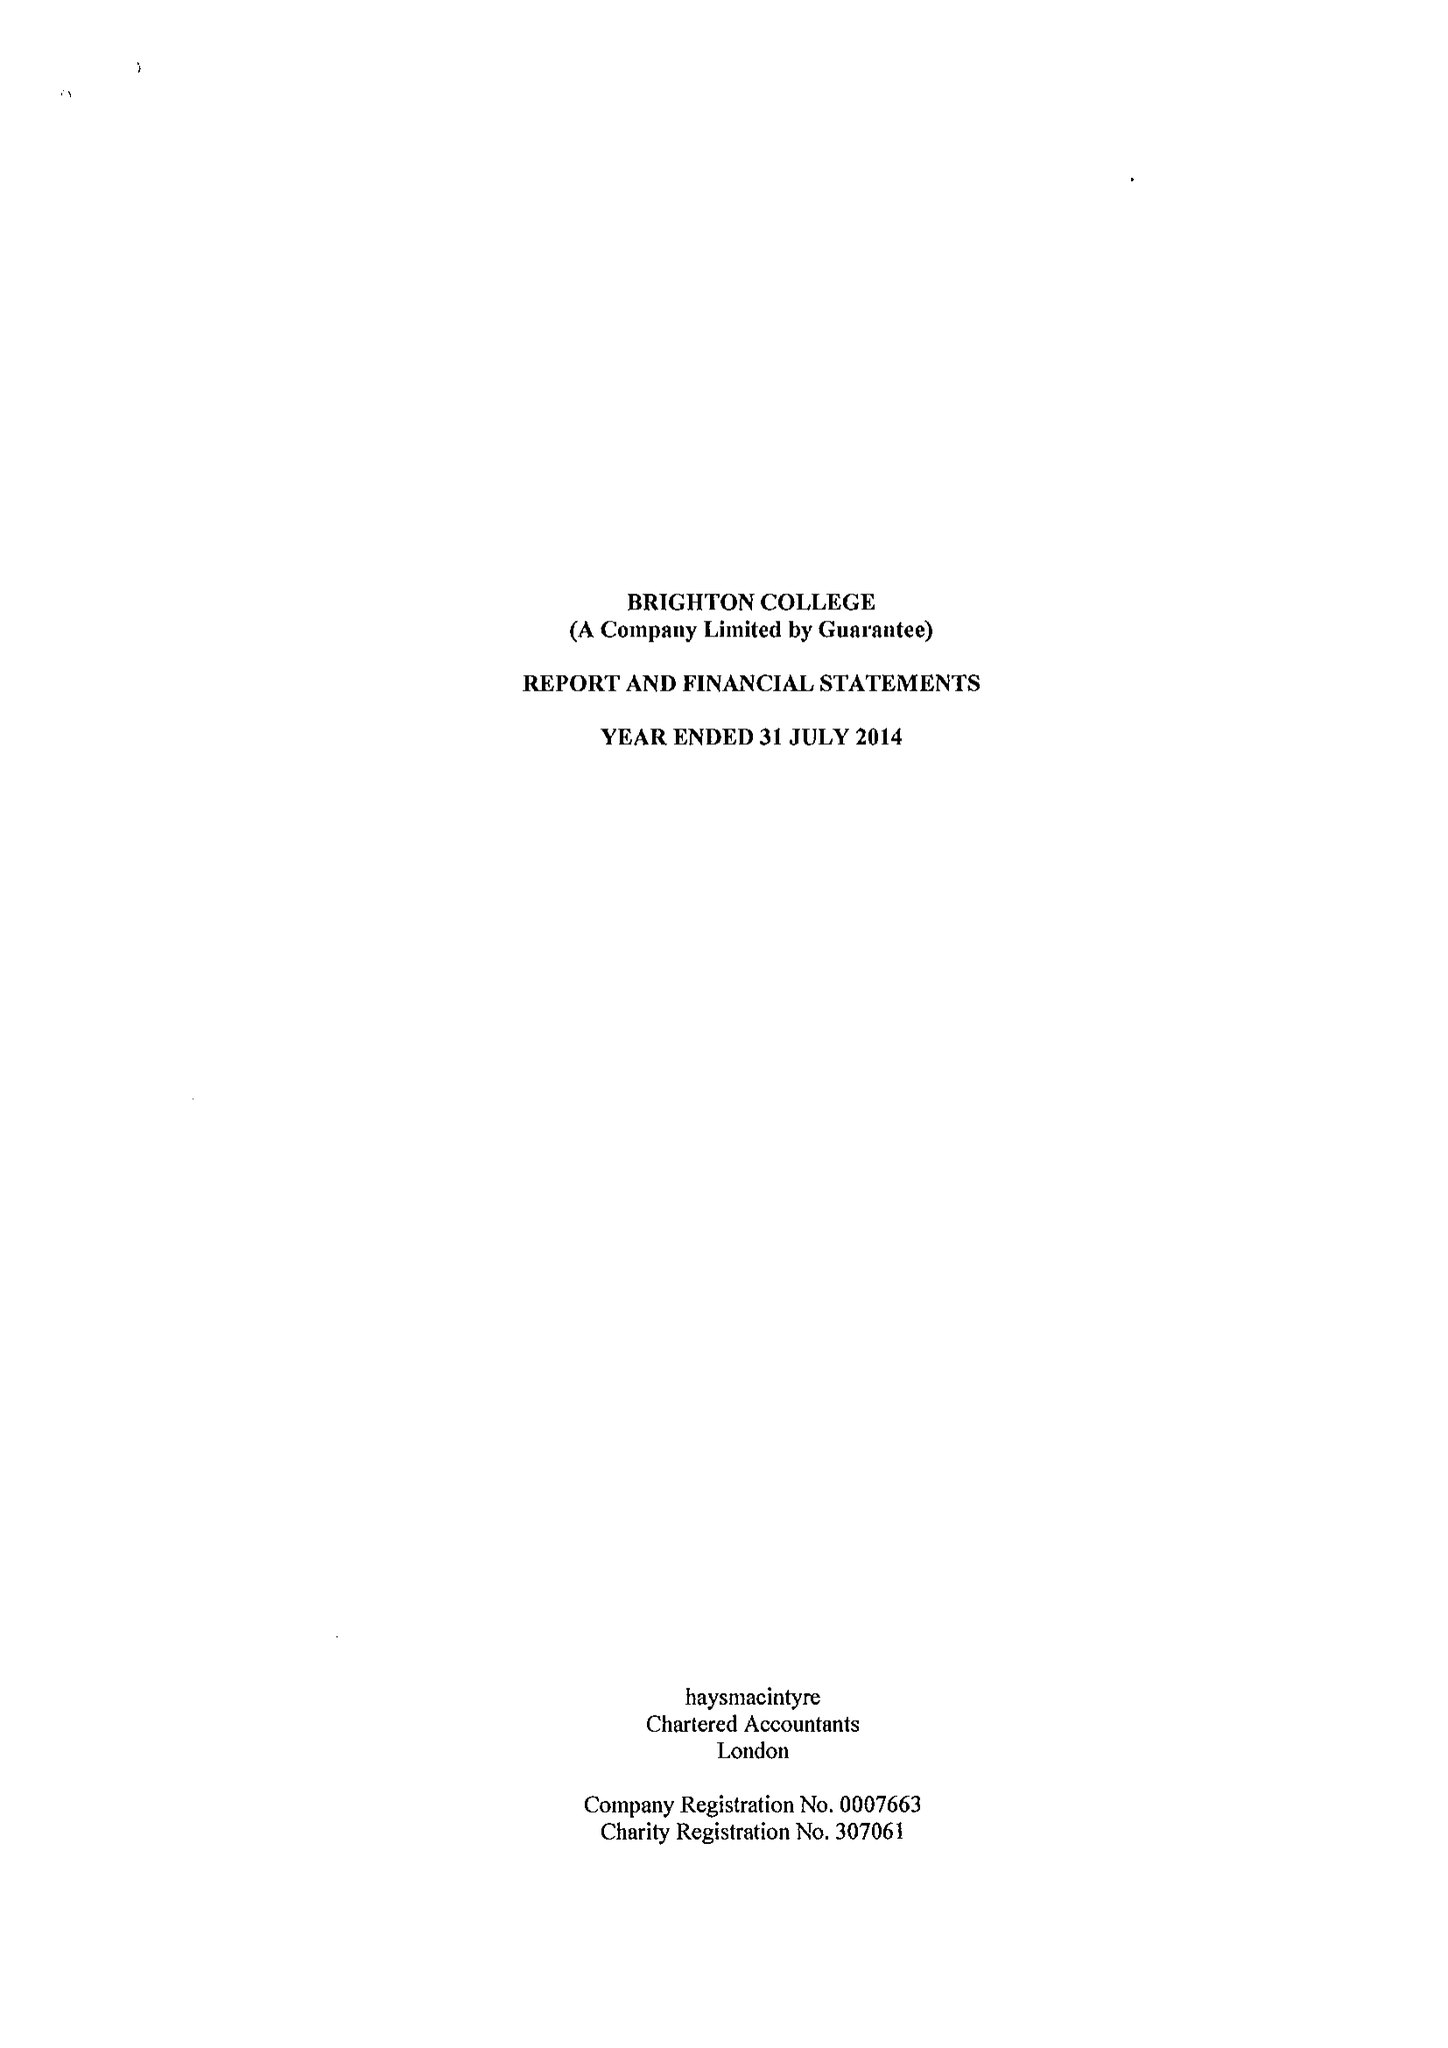What is the value for the charity_name?
Answer the question using a single word or phrase. Brighton College 